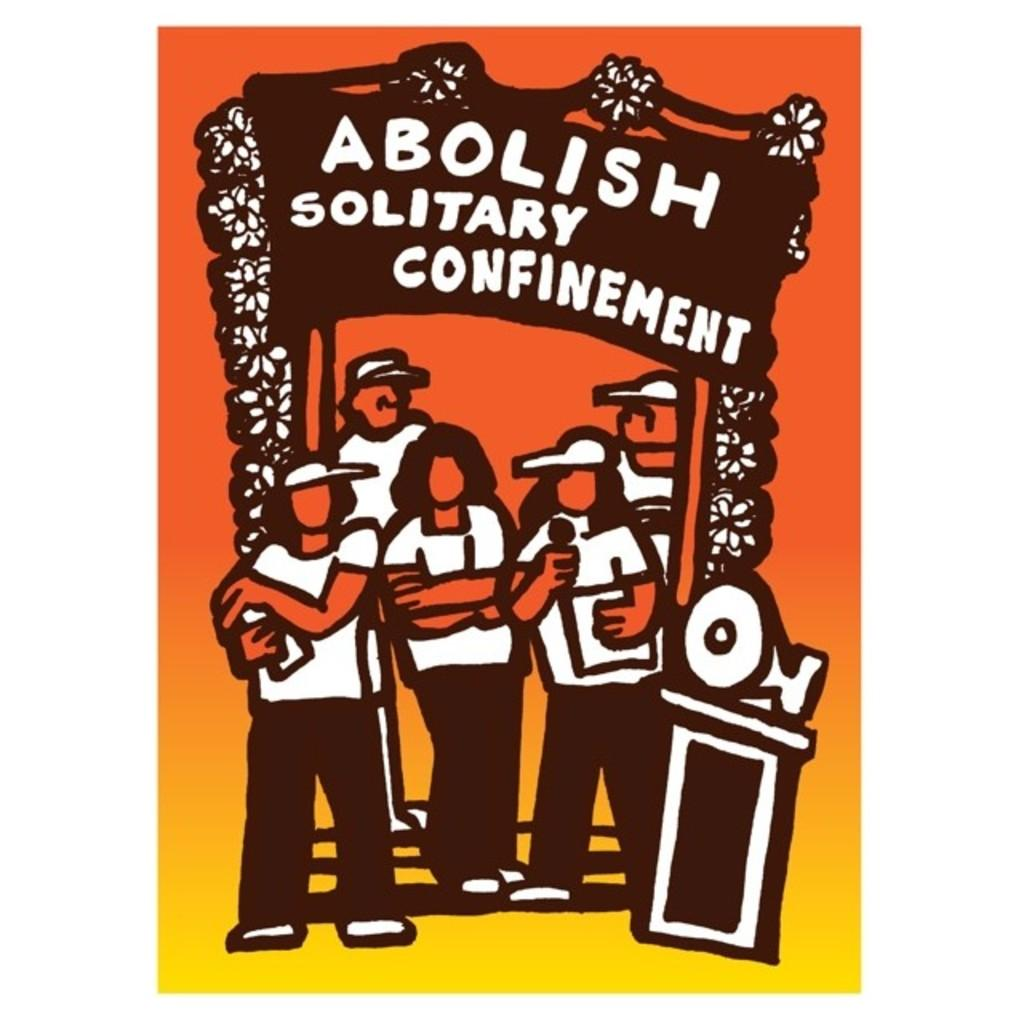<image>
Describe the image concisely. A sign says to "abolish solitary confinement" on a yellow and orange background. 